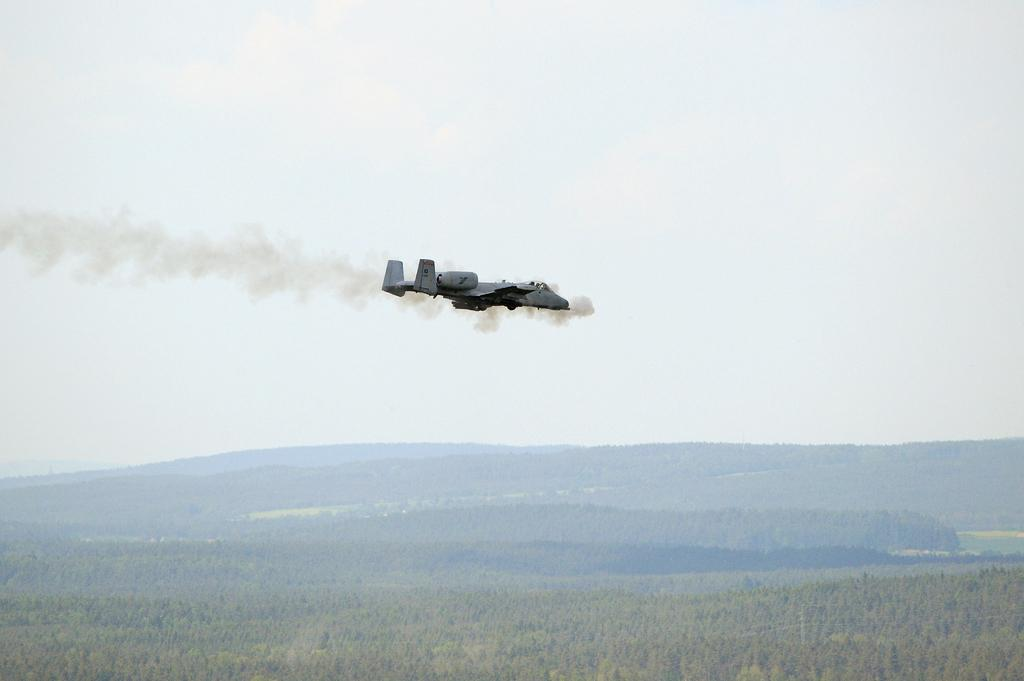What is the main subject of the picture? The main subject of the picture is an aircraft. What can be observed coming from the aircraft? Smoke is coming from the aircraft. What type of vegetation is present on the ground? There are trees on the ground. What is visible in the background of the image? There is a mountain in the background. How is the mountain covered? The mountain is covered with trees. Can you tell me how many snails are crawling on the aircraft in the image? There are no snails present on the aircraft in the image. What type of jewel can be seen hanging from the trees on the mountain? There is no jewel visible in the image; it only features an aircraft, smoke, trees, and a mountain. 